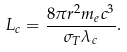<formula> <loc_0><loc_0><loc_500><loc_500>L _ { c } = \frac { 8 \pi r ^ { 2 } m _ { e } c ^ { 3 } } { \sigma _ { T } \lambda _ { c } } .</formula> 